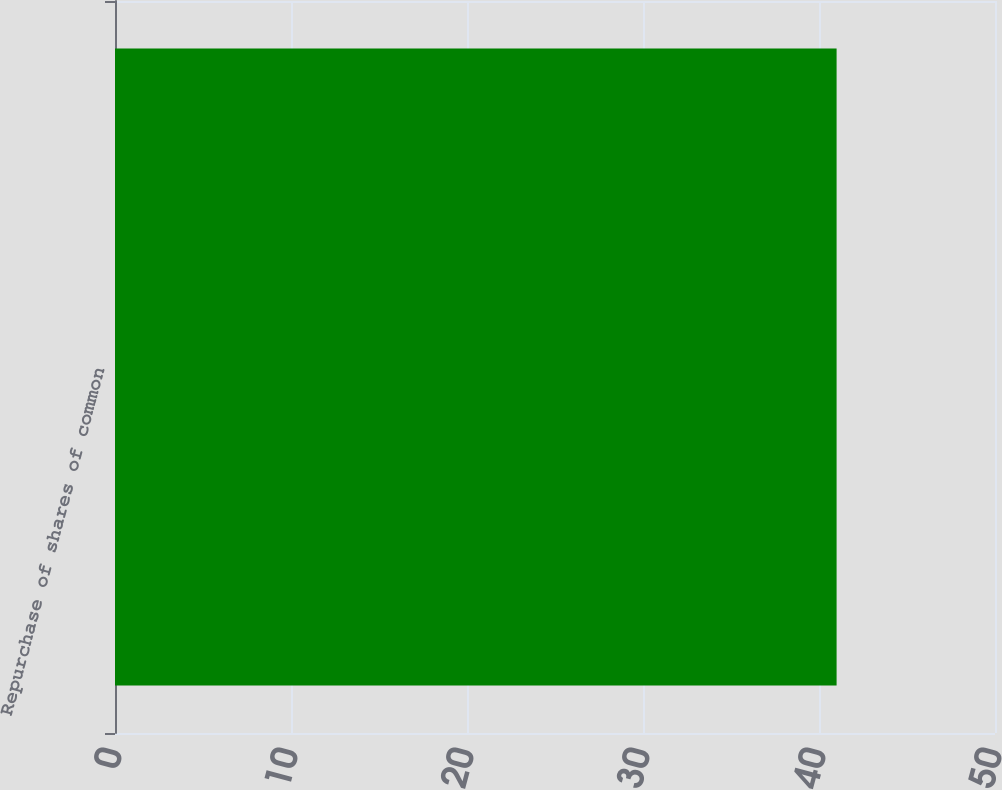Convert chart. <chart><loc_0><loc_0><loc_500><loc_500><bar_chart><fcel>Repurchase of shares of common<nl><fcel>41<nl></chart> 